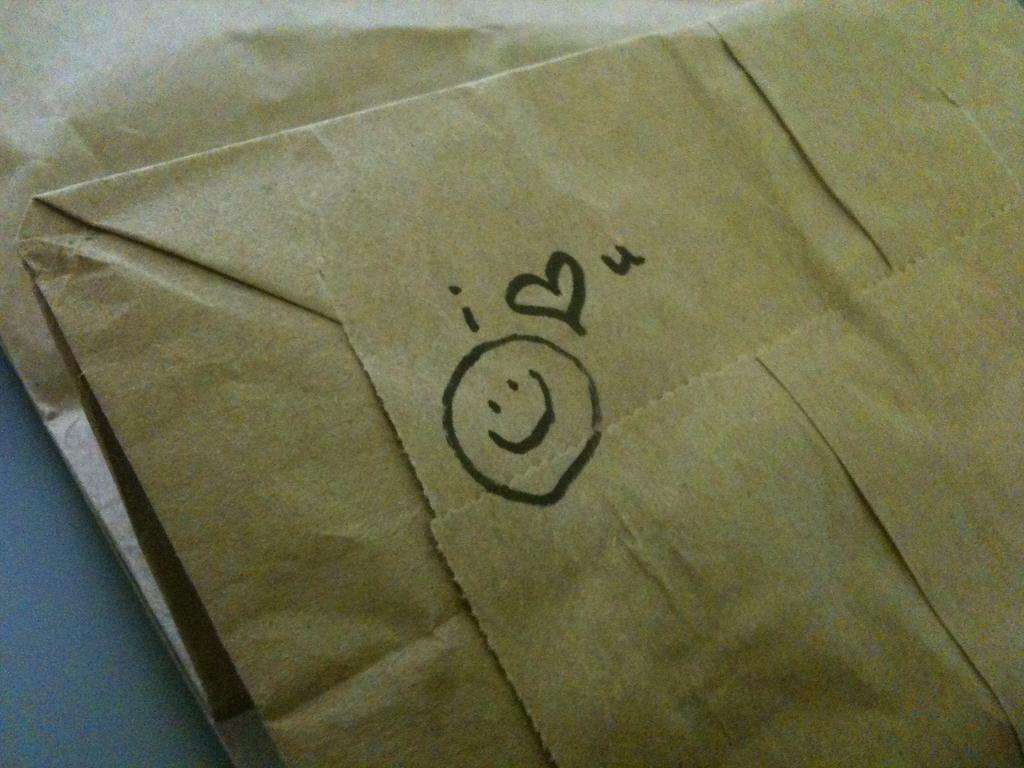<image>
Relay a brief, clear account of the picture shown. A brown paper bag with a drawing of a face and i heart you on it 